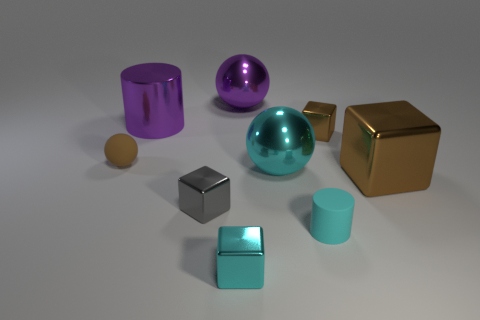Subtract all big blocks. How many blocks are left? 3 Add 1 large yellow metal balls. How many objects exist? 10 Subtract all cylinders. How many objects are left? 7 Subtract all cyan blocks. How many blocks are left? 3 Subtract 2 brown blocks. How many objects are left? 7 Subtract 1 cylinders. How many cylinders are left? 1 Subtract all green cylinders. Subtract all gray cubes. How many cylinders are left? 2 Subtract all green cylinders. How many brown blocks are left? 2 Subtract all big brown matte objects. Subtract all cyan metal blocks. How many objects are left? 8 Add 3 cyan shiny blocks. How many cyan shiny blocks are left? 4 